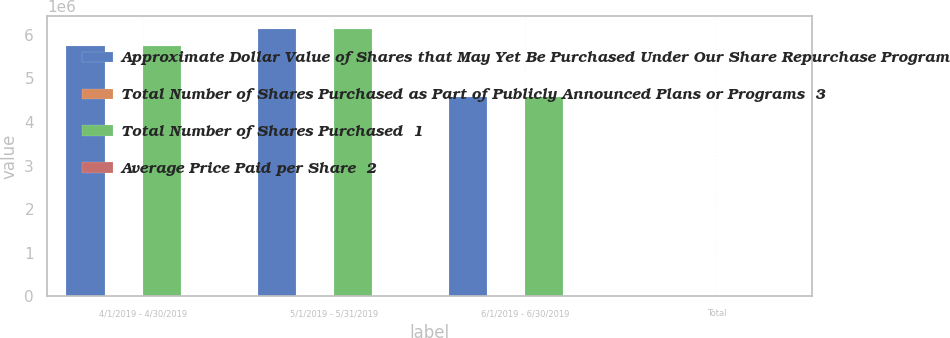<chart> <loc_0><loc_0><loc_500><loc_500><stacked_bar_chart><ecel><fcel>4/1/2019 - 4/30/2019<fcel>5/1/2019 - 5/31/2019<fcel>6/1/2019 - 6/30/2019<fcel>Total<nl><fcel>Approximate Dollar Value of Shares that May Yet Be Purchased Under Our Share Repurchase Program<fcel>5.73921e+06<fcel>6.1253e+06<fcel>4.56757e+06<fcel>107.985<nl><fcel>Total Number of Shares Purchased as Part of Publicly Announced Plans or Programs  3<fcel>104.54<fcel>106.12<fcel>109.47<fcel>106.5<nl><fcel>Total Number of Shares Purchased  1<fcel>5.73921e+06<fcel>6.1253e+06<fcel>4.56757e+06<fcel>107.985<nl><fcel>Average Price Paid per Share  2<fcel>3<fcel>3<fcel>3<fcel>3<nl></chart> 